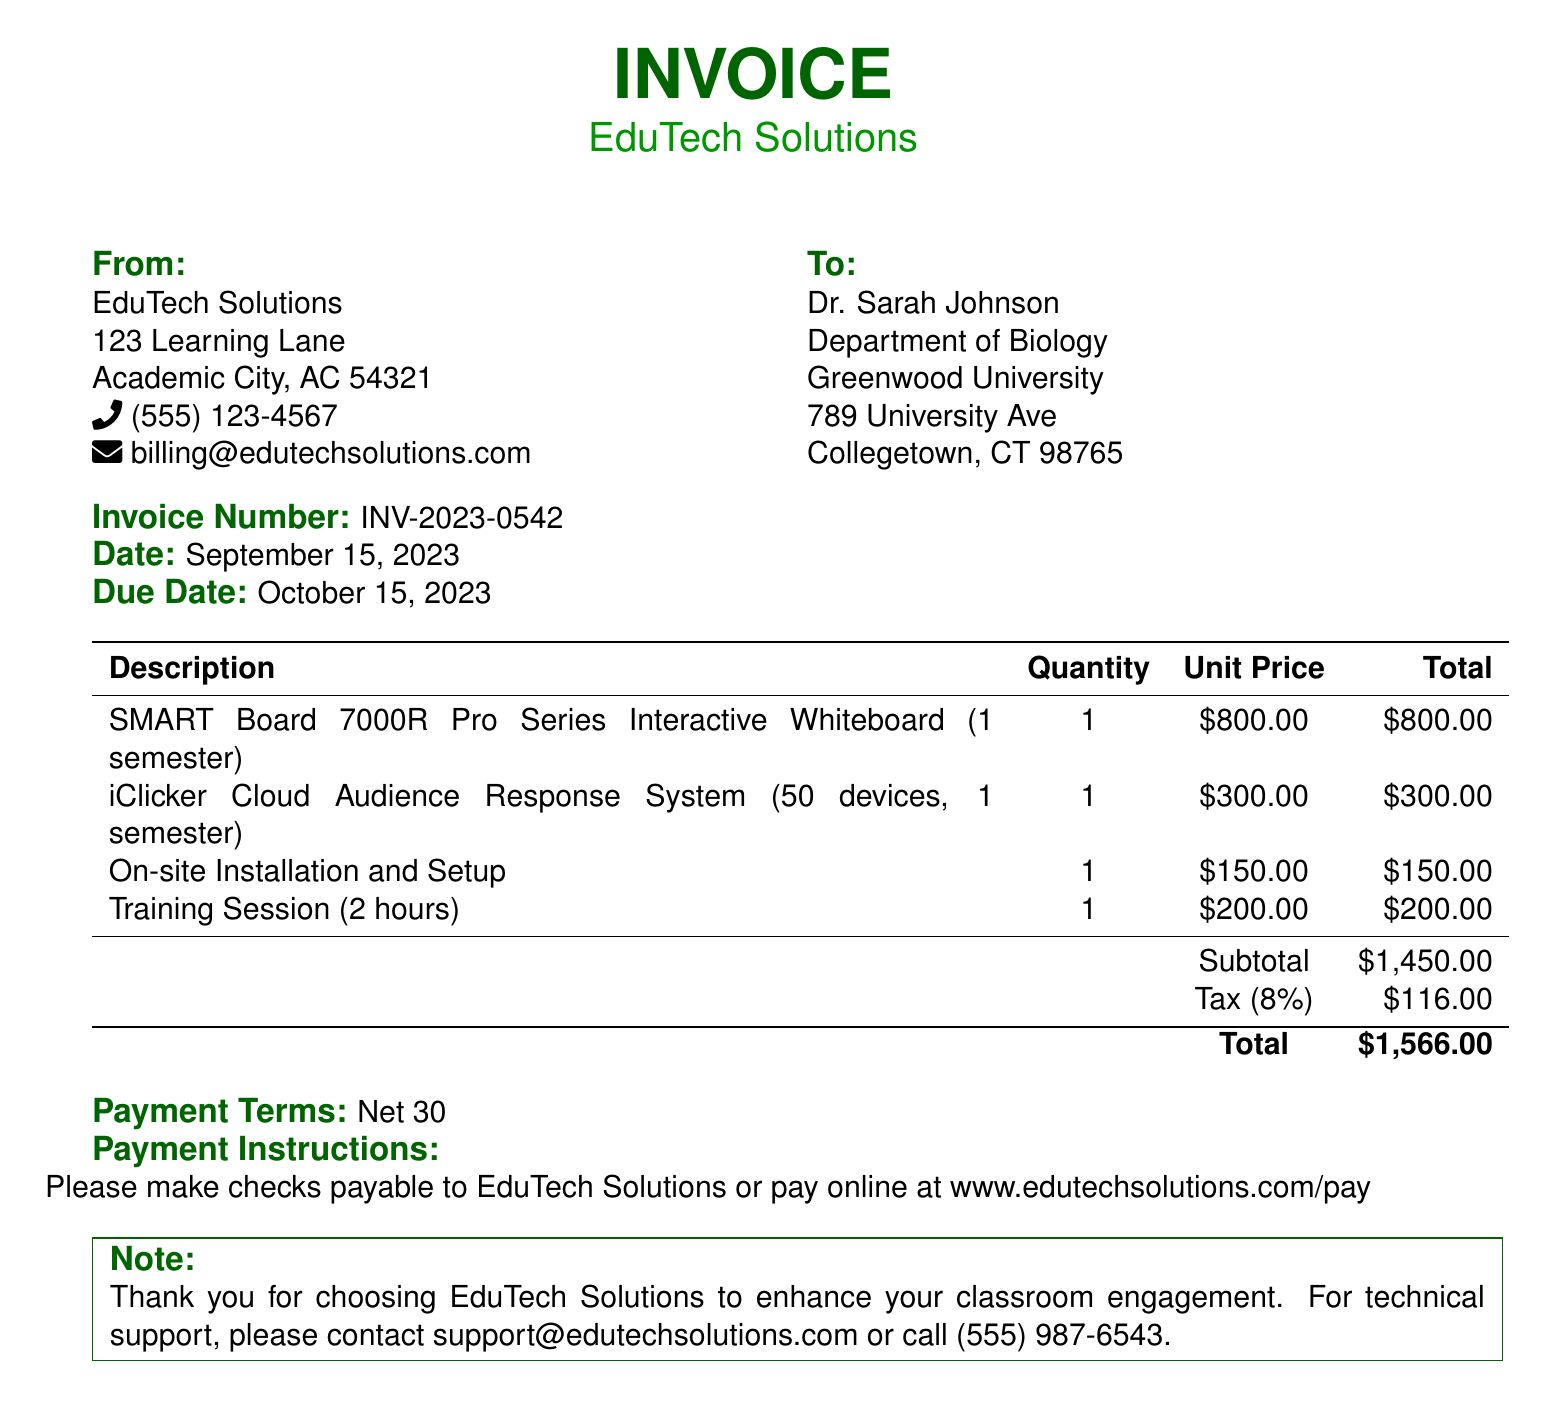What is the invoice number? The invoice number is listed clearly in the document, which identifies this specific transaction.
Answer: INV-2023-0542 What is the due date for payment? The due date is stated in the document as the last date by which payment should be made.
Answer: October 15, 2023 How much is the tax amount? The tax amount is provided in the invoice, calculated as a percentage of the subtotal.
Answer: $116.00 What is the total amount due? The total amount due is the overall cost that includes the subtotal and the tax.
Answer: $1,566.00 Who is the recipient of this invoice? The document specifies the person or entity to which the invoice is addressed.
Answer: Dr. Sarah Johnson What services are included in this invoice? The document lists the items and services that have been billed, giving a clear description of each.
Answer: SMART Board 7000R Pro Series Interactive Whiteboard, iClicker Cloud Audience Response System, On-site Installation and Setup, Training Session How many devices are included in the audience response system? The number of devices is mentioned in the description of the audience response system.
Answer: 50 devices What company issued this invoice? The name of the company providing the services or products in the invoice is included at the top.
Answer: EduTech Solutions What is the contact information for billing inquiries? The document provides specific contact details for any billing-related questions or issues.
Answer: billing@edutechsolutions.com 